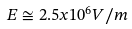Convert formula to latex. <formula><loc_0><loc_0><loc_500><loc_500>E \cong 2 . 5 x 1 0 ^ { 6 } V / m</formula> 